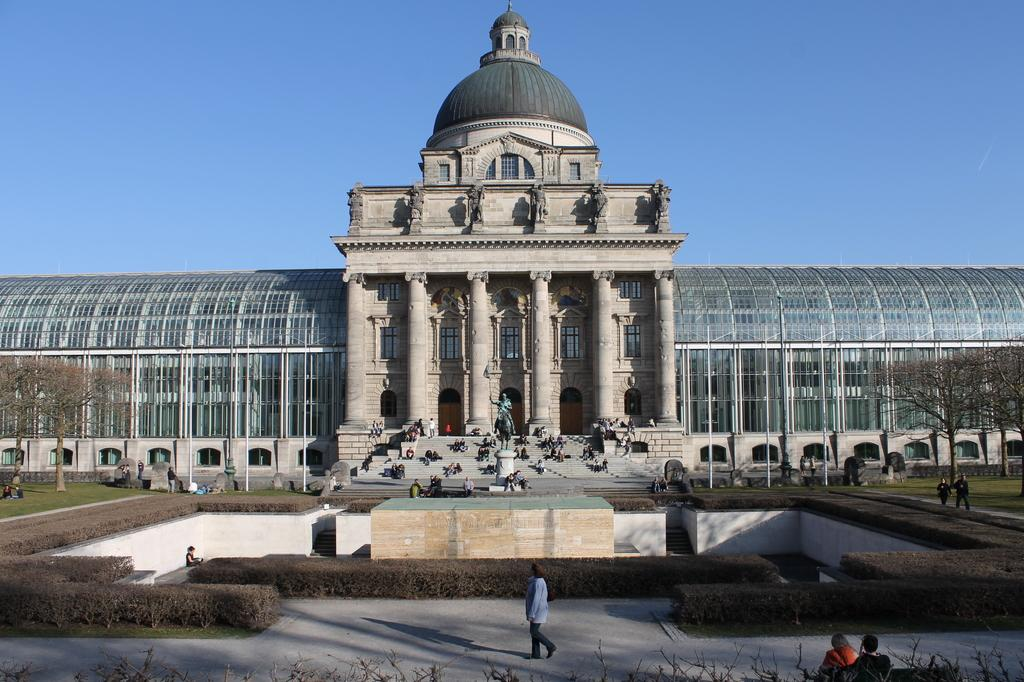What type of structure is visible in the image? There is a building in the image. What other object can be seen near the building? There is a statue in the image. Are there any people in the image? Yes, there are persons in the image. What additional feature is present in the image? There is a fountain in the image. What type of vegetation is present on either side of the building? Trees are present on either side of the building. Can you tell me how many sticks the beggar is holding in the image? There is no beggar or stick present in the image. What type of person is depicted in the statue? The provided facts do not mention any specific person or details about the statue. 